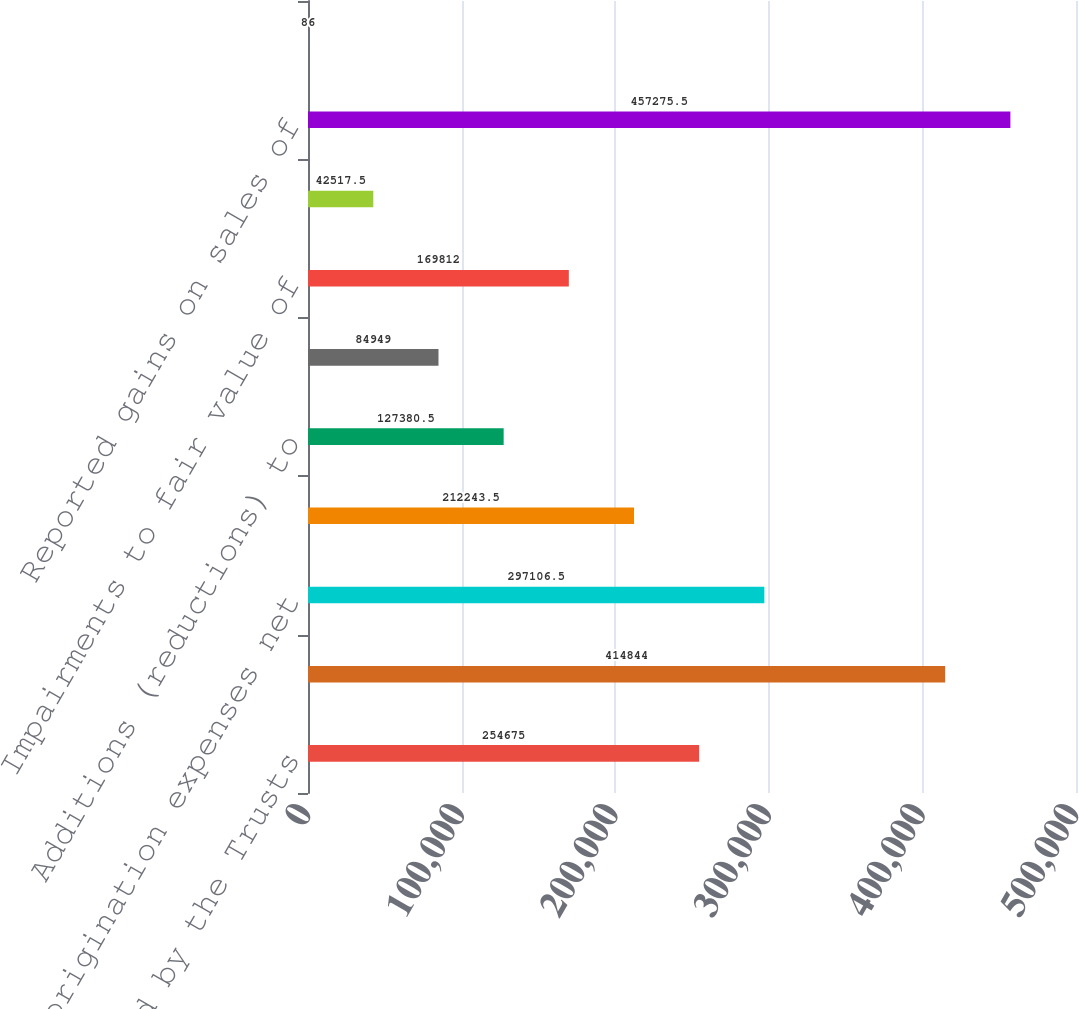<chart> <loc_0><loc_0><loc_500><loc_500><bar_chart><fcel>Whole loans sold by the Trusts<fcel>Loans securitized<fcel>Loan origination expenses net<fcel>Retained mortgage servicing<fcel>Additions (reductions) to<fcel>Changes in beneficial interest<fcel>Impairments to fair value of<fcel>Net change in fair value of<fcel>Reported gains on sales of<fcel>of gains received as cash<nl><fcel>254675<fcel>414844<fcel>297106<fcel>212244<fcel>127380<fcel>84949<fcel>169812<fcel>42517.5<fcel>457276<fcel>86<nl></chart> 